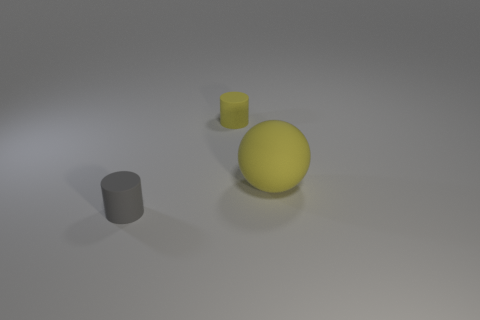Add 3 gray blocks. How many objects exist? 6 Subtract all cylinders. How many objects are left? 1 Subtract 0 purple balls. How many objects are left? 3 Subtract all yellow objects. Subtract all tiny gray matte cylinders. How many objects are left? 0 Add 3 small yellow cylinders. How many small yellow cylinders are left? 4 Add 1 big green cylinders. How many big green cylinders exist? 1 